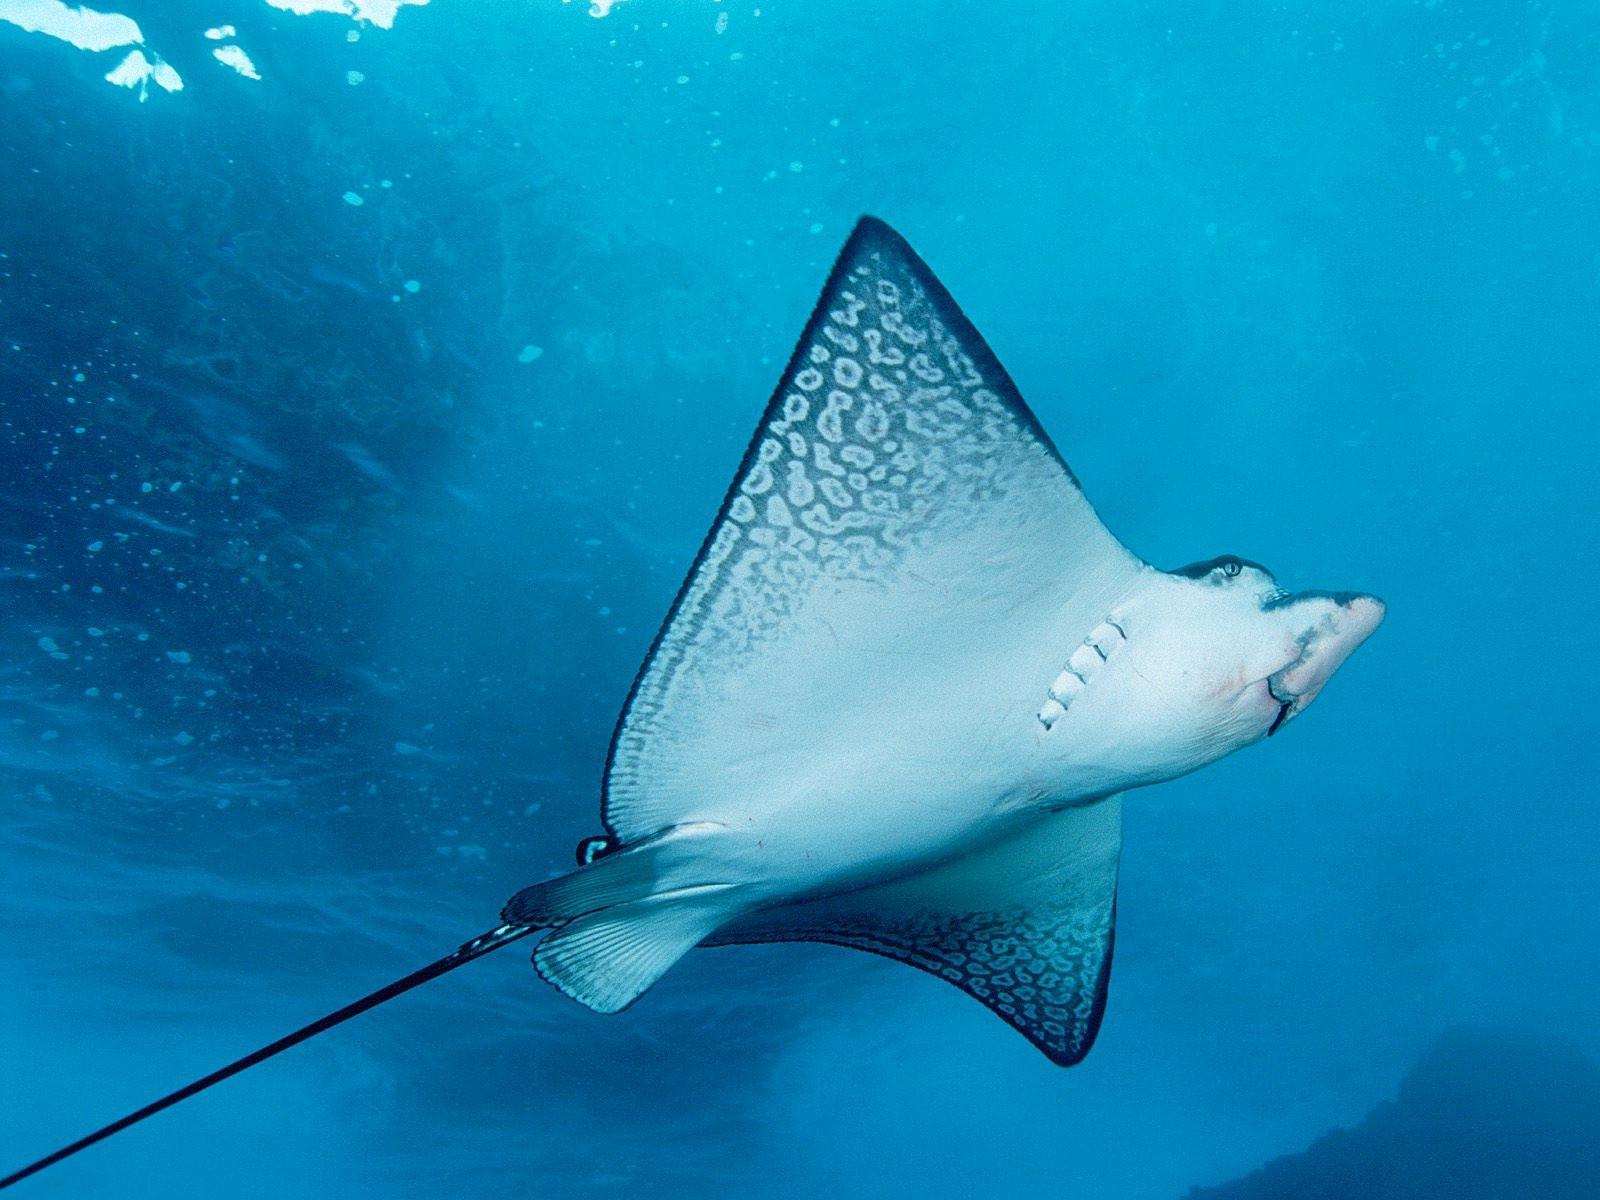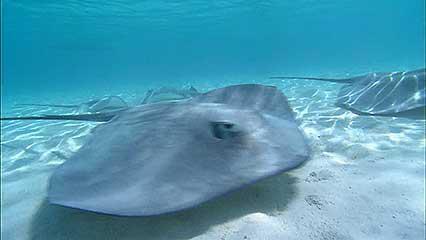The first image is the image on the left, the second image is the image on the right. Considering the images on both sides, is "the left image shows a sea full of stingray from the top view" valid? Answer yes or no. No. The first image is the image on the left, the second image is the image on the right. Assess this claim about the two images: "At least one image in the pair shows a single stingray.". Correct or not? Answer yes or no. Yes. The first image is the image on the left, the second image is the image on the right. Considering the images on both sides, is "The stingray on the left is viewed from underneath, showing its underside." valid? Answer yes or no. Yes. 